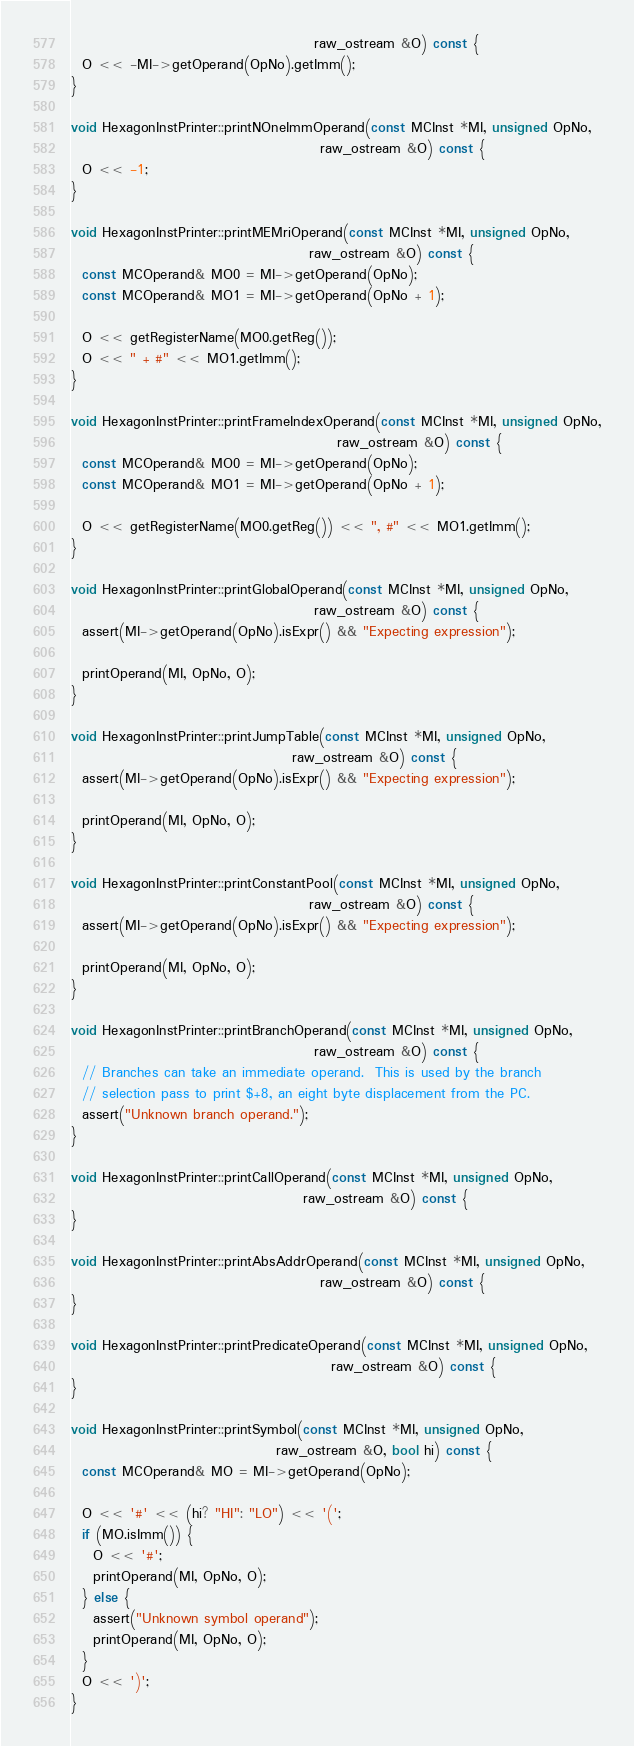<code> <loc_0><loc_0><loc_500><loc_500><_C++_>                                            raw_ostream &O) const {
  O << -MI->getOperand(OpNo).getImm();
}

void HexagonInstPrinter::printNOneImmOperand(const MCInst *MI, unsigned OpNo,
                                             raw_ostream &O) const {
  O << -1;
}

void HexagonInstPrinter::printMEMriOperand(const MCInst *MI, unsigned OpNo,
                                           raw_ostream &O) const {
  const MCOperand& MO0 = MI->getOperand(OpNo);
  const MCOperand& MO1 = MI->getOperand(OpNo + 1);

  O << getRegisterName(MO0.getReg());
  O << " + #" << MO1.getImm();
}

void HexagonInstPrinter::printFrameIndexOperand(const MCInst *MI, unsigned OpNo,
                                                raw_ostream &O) const {
  const MCOperand& MO0 = MI->getOperand(OpNo);
  const MCOperand& MO1 = MI->getOperand(OpNo + 1);

  O << getRegisterName(MO0.getReg()) << ", #" << MO1.getImm();
}

void HexagonInstPrinter::printGlobalOperand(const MCInst *MI, unsigned OpNo,
                                            raw_ostream &O) const {
  assert(MI->getOperand(OpNo).isExpr() && "Expecting expression");

  printOperand(MI, OpNo, O);
}

void HexagonInstPrinter::printJumpTable(const MCInst *MI, unsigned OpNo,
                                        raw_ostream &O) const {
  assert(MI->getOperand(OpNo).isExpr() && "Expecting expression");

  printOperand(MI, OpNo, O);
}

void HexagonInstPrinter::printConstantPool(const MCInst *MI, unsigned OpNo,
                                           raw_ostream &O) const {
  assert(MI->getOperand(OpNo).isExpr() && "Expecting expression");

  printOperand(MI, OpNo, O);
}

void HexagonInstPrinter::printBranchOperand(const MCInst *MI, unsigned OpNo,
                                            raw_ostream &O) const {
  // Branches can take an immediate operand.  This is used by the branch
  // selection pass to print $+8, an eight byte displacement from the PC.
  assert("Unknown branch operand.");
}

void HexagonInstPrinter::printCallOperand(const MCInst *MI, unsigned OpNo,
                                          raw_ostream &O) const {
}

void HexagonInstPrinter::printAbsAddrOperand(const MCInst *MI, unsigned OpNo,
                                             raw_ostream &O) const {
}

void HexagonInstPrinter::printPredicateOperand(const MCInst *MI, unsigned OpNo,
                                               raw_ostream &O) const {
}

void HexagonInstPrinter::printSymbol(const MCInst *MI, unsigned OpNo,
                                     raw_ostream &O, bool hi) const {
  const MCOperand& MO = MI->getOperand(OpNo);

  O << '#' << (hi? "HI": "LO") << '(';
  if (MO.isImm()) {
    O << '#';
    printOperand(MI, OpNo, O);
  } else {
    assert("Unknown symbol operand");
    printOperand(MI, OpNo, O);
  }
  O << ')';
}
</code> 